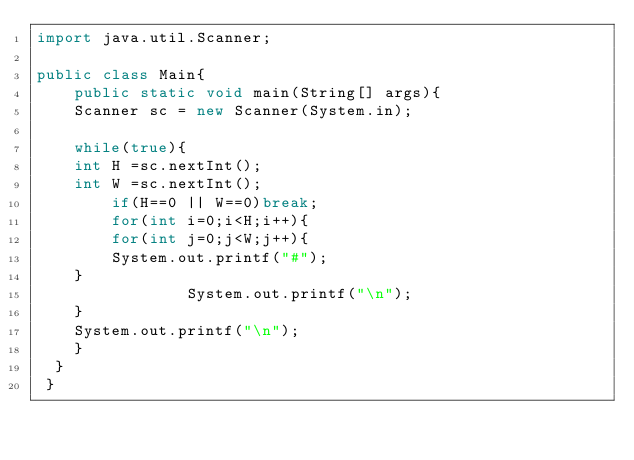Convert code to text. <code><loc_0><loc_0><loc_500><loc_500><_Java_>import java.util.Scanner;

public class Main{
    public static void main(String[] args){
	Scanner sc = new Scanner(System.in);

	while(true){
	int H =sc.nextInt();
	int W =sc.nextInt();
        if(H==0 || W==0)break;
        for(int i=0;i<H;i++){
	    for(int j=0;j<W;j++){
		System.out.printf("#");
	}
                System.out.printf("\n");
	}
	System.out.printf("\n");
	}
  }
 }</code> 